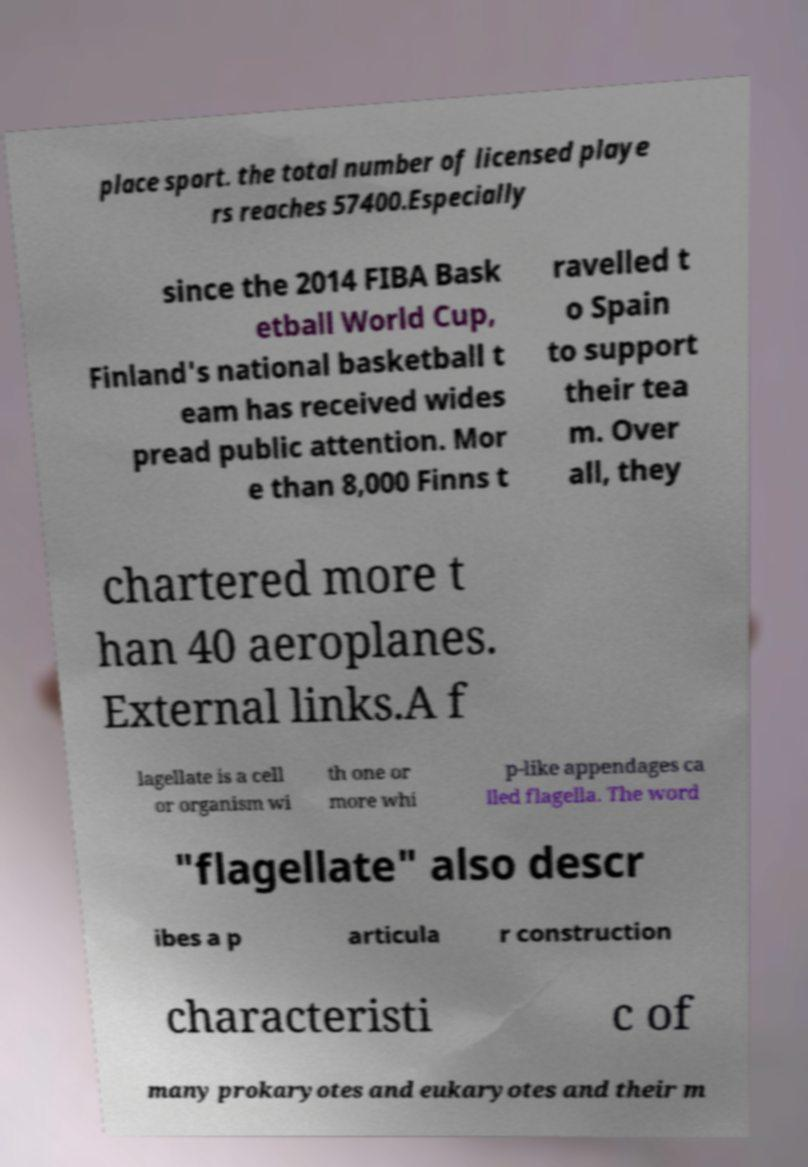For documentation purposes, I need the text within this image transcribed. Could you provide that? place sport. the total number of licensed playe rs reaches 57400.Especially since the 2014 FIBA Bask etball World Cup, Finland's national basketball t eam has received wides pread public attention. Mor e than 8,000 Finns t ravelled t o Spain to support their tea m. Over all, they chartered more t han 40 aeroplanes. External links.A f lagellate is a cell or organism wi th one or more whi p-like appendages ca lled flagella. The word "flagellate" also descr ibes a p articula r construction characteristi c of many prokaryotes and eukaryotes and their m 